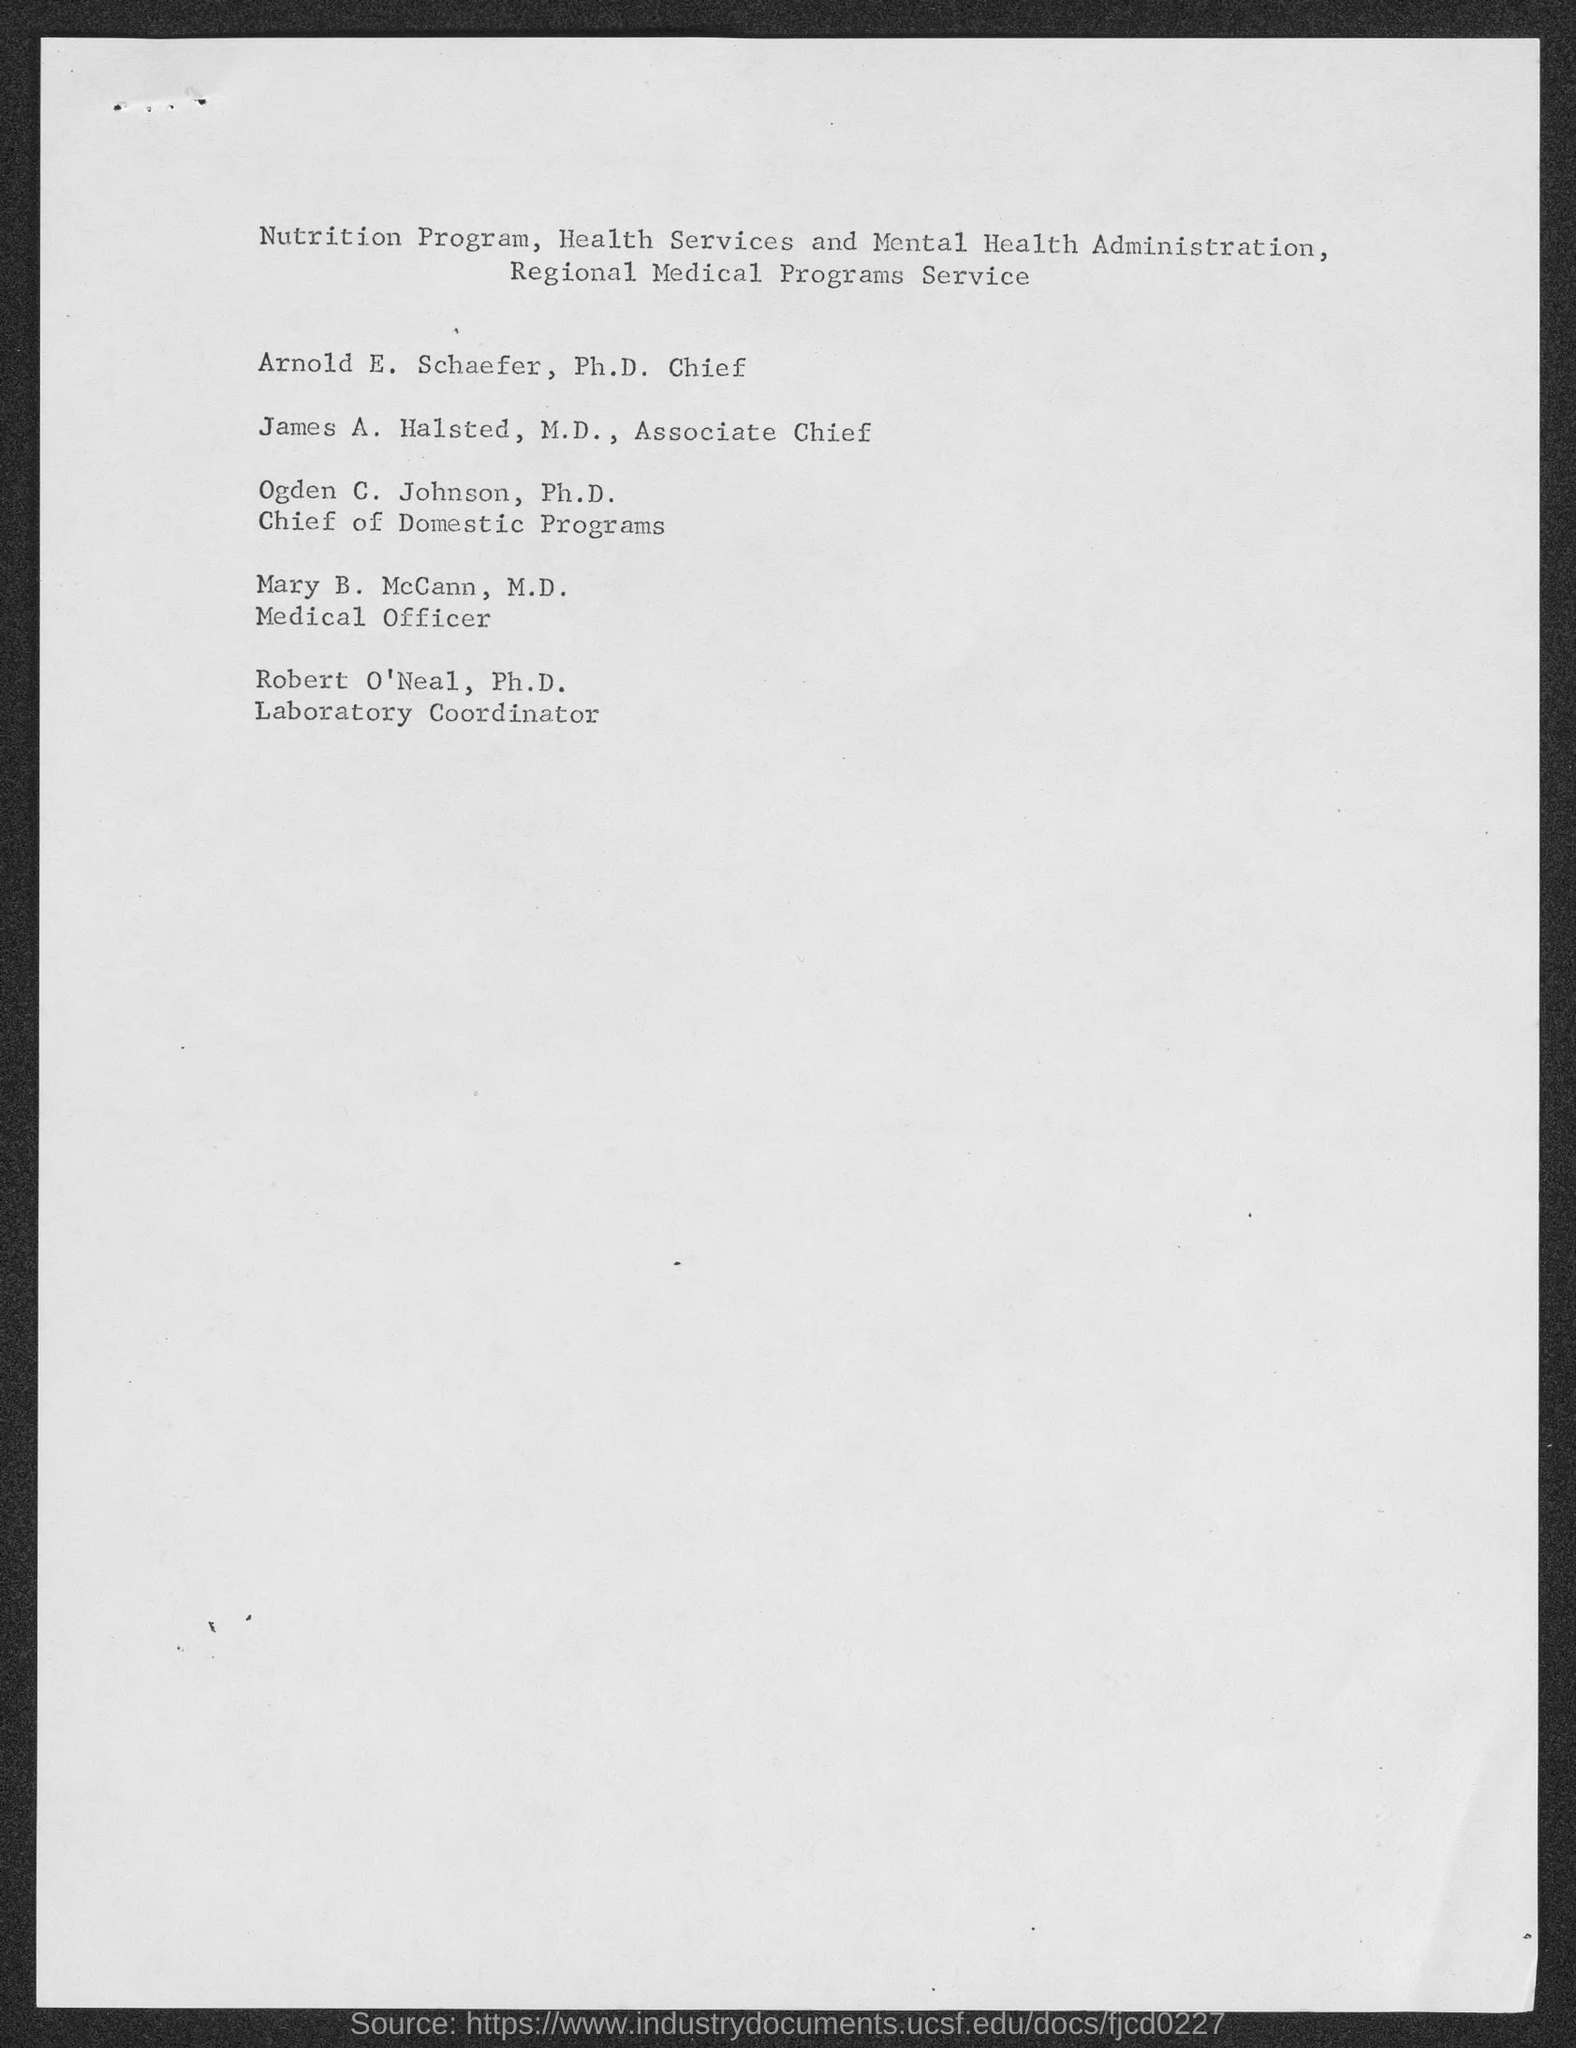Who is the Ph. D. Chief?
Provide a succinct answer. Arnold E. Schaefer. What is the title of James A. Halsted, M.D.?
Your answer should be very brief. Associate chief. Who is Ogden C. Johnson, Ph. D.?
Your answer should be compact. Chief of domestic programs. Who is the Laboratory Coordinator?
Your response must be concise. Robert O'Neal, Ph.D. 